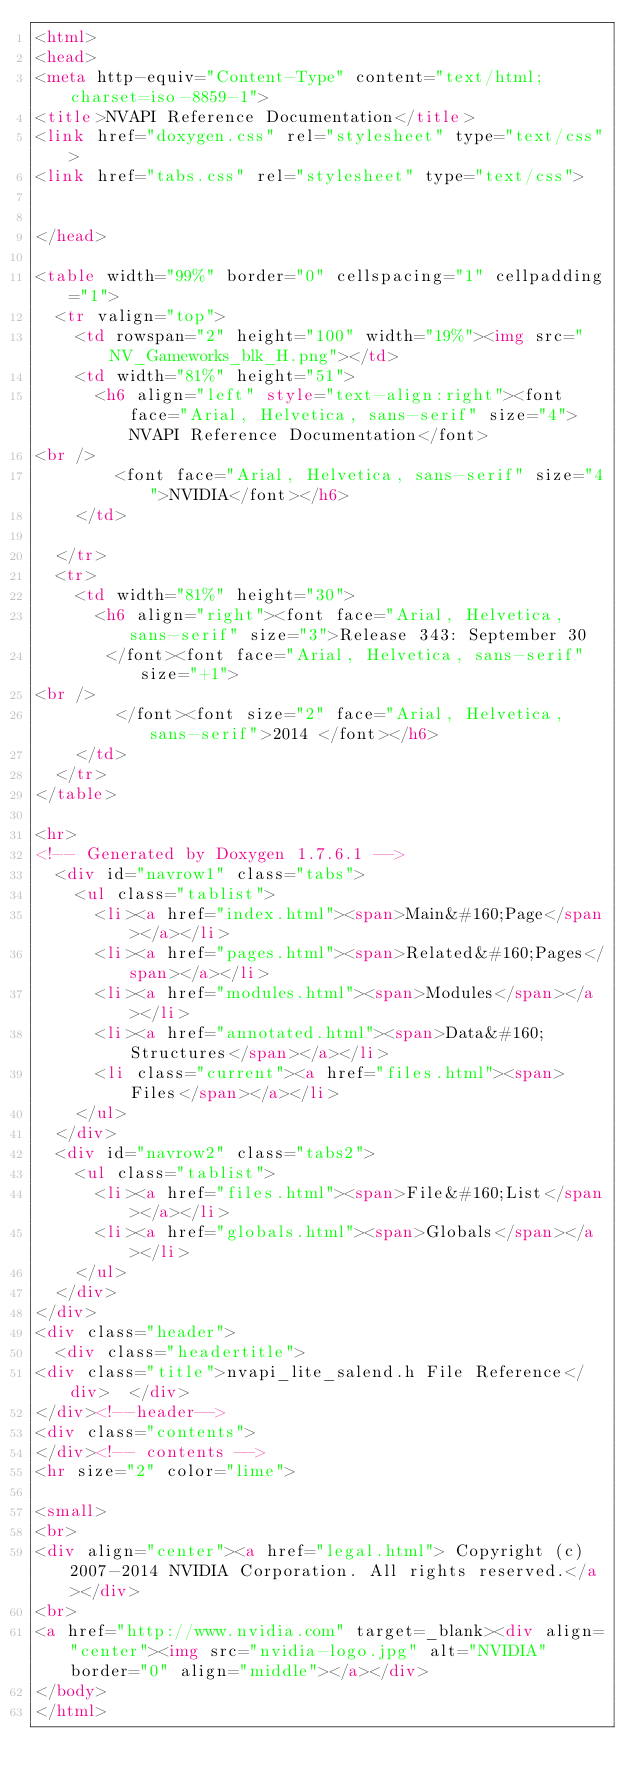Convert code to text. <code><loc_0><loc_0><loc_500><loc_500><_HTML_><html>
<head>
<meta http-equiv="Content-Type" content="text/html;charset=iso-8859-1">
<title>NVAPI Reference Documentation</title>
<link href="doxygen.css" rel="stylesheet" type="text/css">
<link href="tabs.css" rel="stylesheet" type="text/css">


</head>

<table width="99%" border="0" cellspacing="1" cellpadding="1">
  <tr valign="top"> 
    <td rowspan="2" height="100" width="19%"><img src="NV_Gameworks_blk_H.png"></td>
    <td width="81%" height="51"> 
      <h6 align="left" style="text-align:right"><font face="Arial, Helvetica, sans-serif" size="4">NVAPI Reference Documentation</font>
<br />
        <font face="Arial, Helvetica, sans-serif" size="4">NVIDIA</font></h6>
    </td>

  </tr>
  <tr> 
    <td width="81%" height="30">
      <h6 align="right"><font face="Arial, Helvetica, sans-serif" size="3">Release 343: September 30 
       </font><font face="Arial, Helvetica, sans-serif" size="+1">
<br />
        </font><font size="2" face="Arial, Helvetica, sans-serif">2014 </font></h6>
    </td>
  </tr>
</table>

<hr>
<!-- Generated by Doxygen 1.7.6.1 -->
  <div id="navrow1" class="tabs">
    <ul class="tablist">
      <li><a href="index.html"><span>Main&#160;Page</span></a></li>
      <li><a href="pages.html"><span>Related&#160;Pages</span></a></li>
      <li><a href="modules.html"><span>Modules</span></a></li>
      <li><a href="annotated.html"><span>Data&#160;Structures</span></a></li>
      <li class="current"><a href="files.html"><span>Files</span></a></li>
    </ul>
  </div>
  <div id="navrow2" class="tabs2">
    <ul class="tablist">
      <li><a href="files.html"><span>File&#160;List</span></a></li>
      <li><a href="globals.html"><span>Globals</span></a></li>
    </ul>
  </div>
</div>
<div class="header">
  <div class="headertitle">
<div class="title">nvapi_lite_salend.h File Reference</div>  </div>
</div><!--header-->
<div class="contents">
</div><!-- contents -->
<hr size="2" color="lime">

<small>
<br>
<div align="center"><a href="legal.html"> Copyright (c) 2007-2014 NVIDIA Corporation. All rights reserved.</a></div>
<br>
<a href="http://www.nvidia.com" target=_blank><div align="center"><img src="nvidia-logo.jpg" alt="NVIDIA" border="0" align="middle"></a></div>
</body>
</html>
</code> 